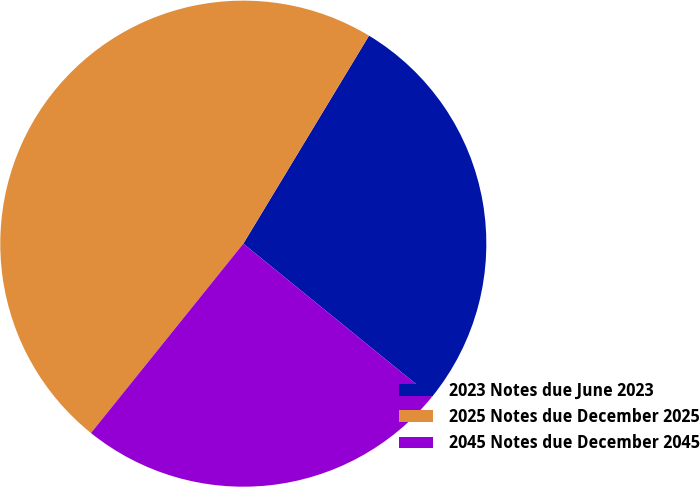Convert chart. <chart><loc_0><loc_0><loc_500><loc_500><pie_chart><fcel>2023 Notes due June 2023<fcel>2025 Notes due December 2025<fcel>2045 Notes due December 2045<nl><fcel>27.21%<fcel>47.87%<fcel>24.92%<nl></chart> 